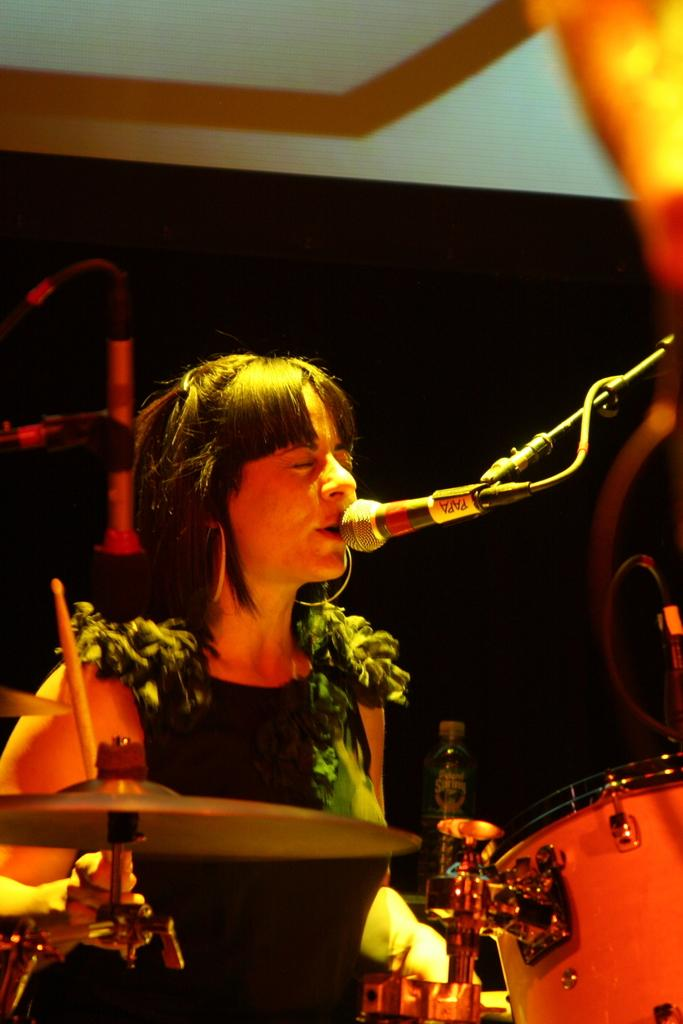Who is the main subject in the image? There is a woman in the image. What is the woman doing in the image? The woman is singing into a microphone. What other objects related to music can be seen in the image? There are musical instruments in the image. What is the background of the image? There is a wall in the image. What item is present for disposing of liquids? There is a disposal bottle in the image. What type of creature is playing the musical instruments in the image? There is no creature playing the musical instruments in the image; it is a woman singing into a microphone, and the musical instruments are likely being played by other people. 